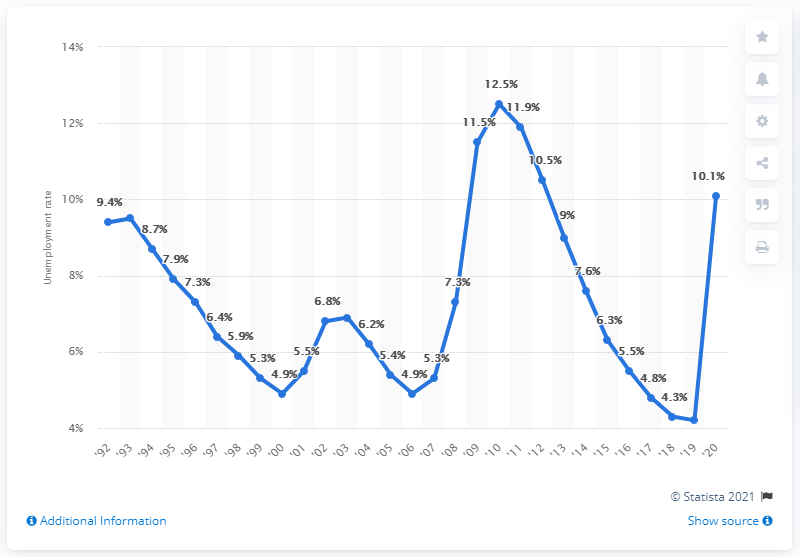Outline some significant characteristics in this image. At its peak, unemployment in California was reached in the year 2010. In 2020, the unemployment rate in California was 10.1%. Unemployment decreased by 2.4% from 2010 to 2020. 